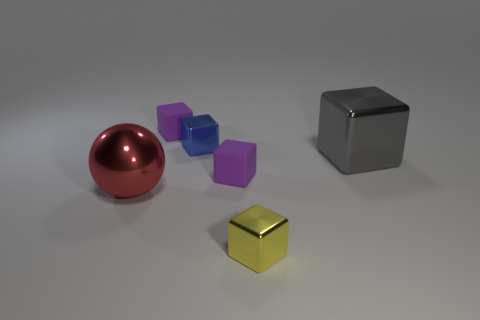There is a tiny yellow metallic thing; is its shape the same as the large thing that is left of the yellow shiny block?
Ensure brevity in your answer.  No. Are there any other things that are the same shape as the small yellow object?
Ensure brevity in your answer.  Yes. Is the material of the big gray object the same as the big object to the left of the yellow shiny object?
Offer a terse response. Yes. There is a large metal object on the right side of the tiny shiny cube that is in front of the block right of the small yellow metal cube; what color is it?
Make the answer very short. Gray. Is there anything else that is the same size as the sphere?
Give a very brief answer. Yes. There is a large block; is its color the same as the tiny shiny cube that is behind the yellow metallic thing?
Offer a very short reply. No. What color is the big metal cube?
Provide a succinct answer. Gray. The big thing that is right of the small metal object that is in front of the large metal object that is behind the large red thing is what shape?
Give a very brief answer. Cube. How many other things are there of the same color as the big sphere?
Offer a very short reply. 0. Are there more tiny purple things in front of the blue metal cube than gray things in front of the gray metal cube?
Your answer should be compact. Yes. 